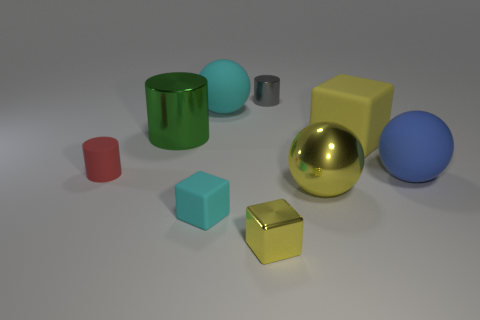There is a large ball that is both behind the yellow shiny ball and on the left side of the large yellow rubber thing; what is its color? The large ball located behind the glossy yellow sphere and to the left of the bulky yellow cube appears to have a cyan hue, exhibiting a refreshing and calming color reminiscent of a clear sky. 